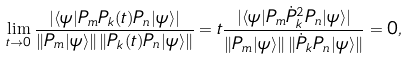<formula> <loc_0><loc_0><loc_500><loc_500>\lim _ { t \to 0 } \frac { | \langle \psi | P _ { m } P _ { k } ( t ) P _ { n } | \psi \rangle | } { \| P _ { m } | \psi \rangle \| \, \| P _ { k } ( t ) P _ { n } | \psi \rangle \| } = t \frac { | \langle \psi | P _ { m } \dot { P } _ { k } ^ { 2 } P _ { n } | \psi \rangle | } { \| P _ { m } | \psi \rangle \| \, \| \dot { P } _ { k } P _ { n } | \psi \rangle \| } = 0 ,</formula> 